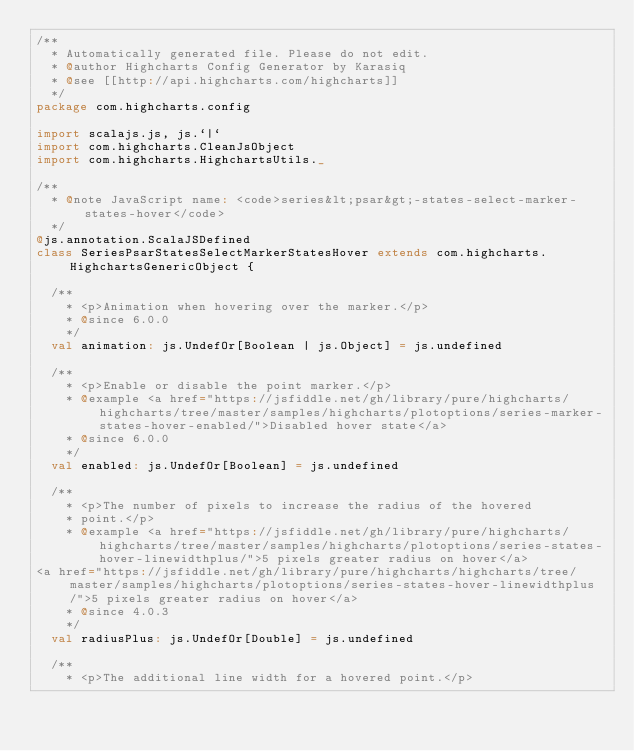Convert code to text. <code><loc_0><loc_0><loc_500><loc_500><_Scala_>/**
  * Automatically generated file. Please do not edit.
  * @author Highcharts Config Generator by Karasiq
  * @see [[http://api.highcharts.com/highcharts]]
  */
package com.highcharts.config

import scalajs.js, js.`|`
import com.highcharts.CleanJsObject
import com.highcharts.HighchartsUtils._

/**
  * @note JavaScript name: <code>series&lt;psar&gt;-states-select-marker-states-hover</code>
  */
@js.annotation.ScalaJSDefined
class SeriesPsarStatesSelectMarkerStatesHover extends com.highcharts.HighchartsGenericObject {

  /**
    * <p>Animation when hovering over the marker.</p>
    * @since 6.0.0
    */
  val animation: js.UndefOr[Boolean | js.Object] = js.undefined

  /**
    * <p>Enable or disable the point marker.</p>
    * @example <a href="https://jsfiddle.net/gh/library/pure/highcharts/highcharts/tree/master/samples/highcharts/plotoptions/series-marker-states-hover-enabled/">Disabled hover state</a>
    * @since 6.0.0
    */
  val enabled: js.UndefOr[Boolean] = js.undefined

  /**
    * <p>The number of pixels to increase the radius of the hovered
    * point.</p>
    * @example <a href="https://jsfiddle.net/gh/library/pure/highcharts/highcharts/tree/master/samples/highcharts/plotoptions/series-states-hover-linewidthplus/">5 pixels greater radius on hover</a>
<a href="https://jsfiddle.net/gh/library/pure/highcharts/highcharts/tree/master/samples/highcharts/plotoptions/series-states-hover-linewidthplus/">5 pixels greater radius on hover</a>
    * @since 4.0.3
    */
  val radiusPlus: js.UndefOr[Double] = js.undefined

  /**
    * <p>The additional line width for a hovered point.</p></code> 